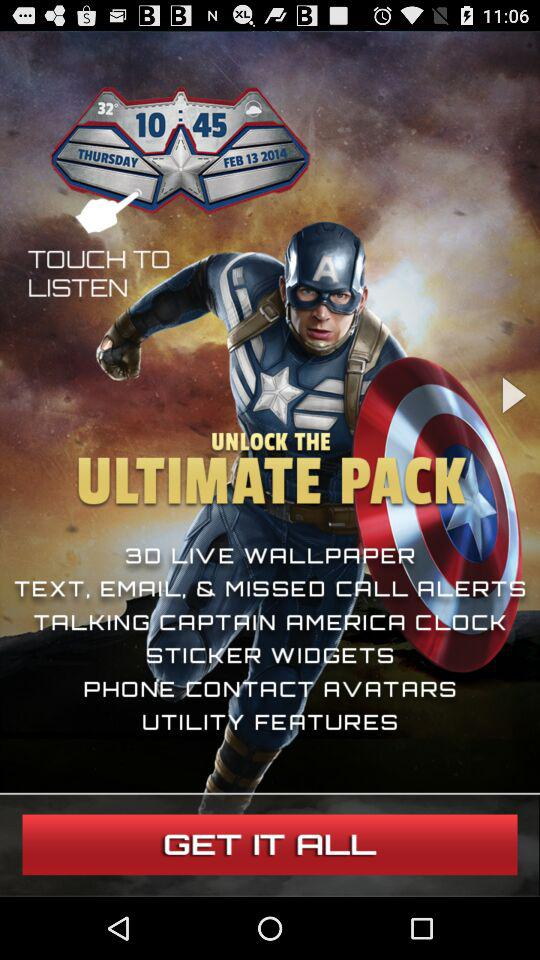What is the temperature shown on the screen? The temperature shown on the screen is 32°. 